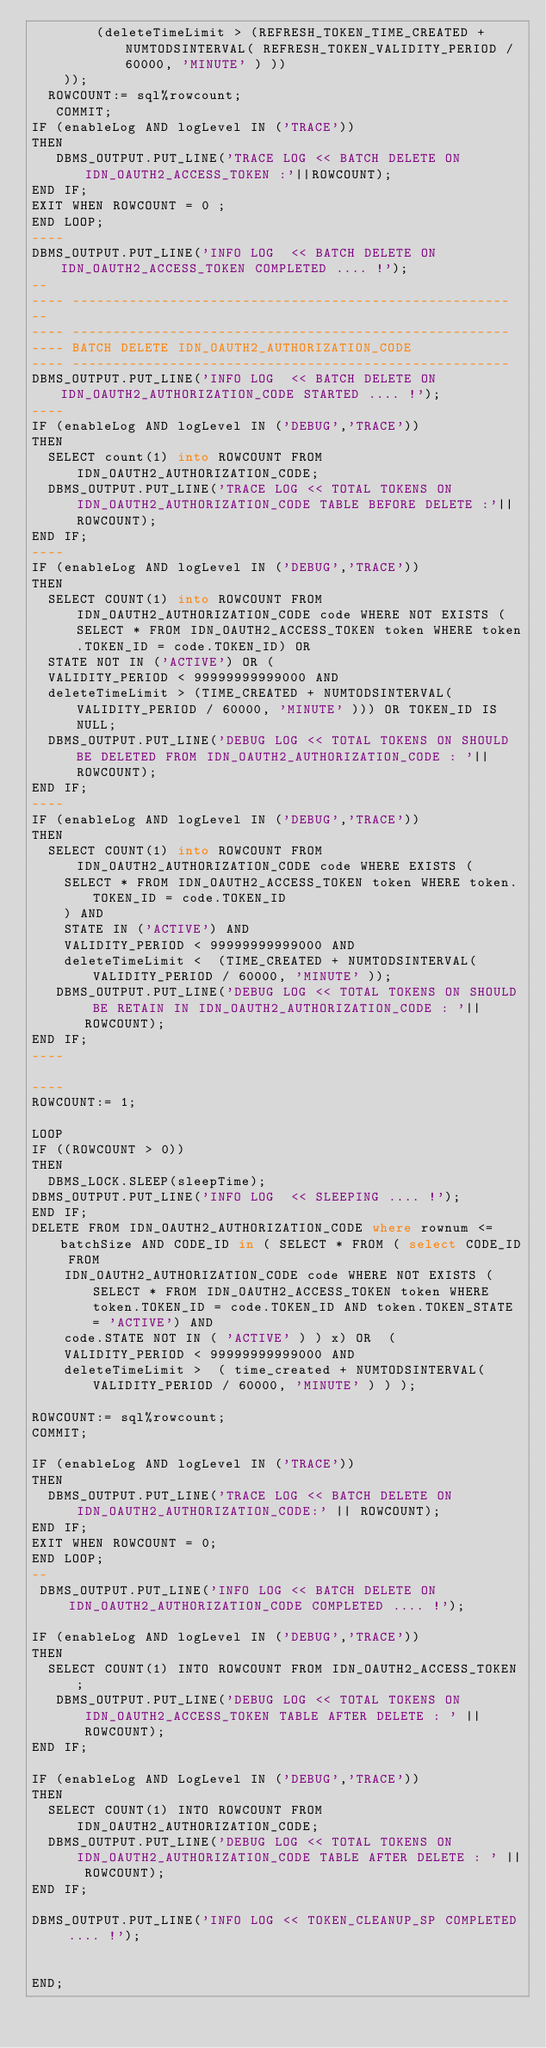<code> <loc_0><loc_0><loc_500><loc_500><_SQL_>        (deleteTimeLimit > (REFRESH_TOKEN_TIME_CREATED + NUMTODSINTERVAL( REFRESH_TOKEN_VALIDITY_PERIOD / 60000, 'MINUTE' ) ))
    ));
  ROWCOUNT:= sql%rowcount;
   COMMIT;
IF (enableLog AND logLevel IN ('TRACE'))
THEN
   DBMS_OUTPUT.PUT_LINE('TRACE LOG << BATCH DELETE ON IDN_OAUTH2_ACCESS_TOKEN :'||ROWCOUNT);
END IF;
EXIT WHEN ROWCOUNT = 0 ;
END LOOP;
----
DBMS_OUTPUT.PUT_LINE('INFO LOG  << BATCH DELETE ON IDN_OAUTH2_ACCESS_TOKEN COMPLETED .... !');
--
---- ------------------------------------------------------
--
---- ------------------------------------------------------
---- BATCH DELETE IDN_OAUTH2_AUTHORIZATION_CODE
---- ------------------------------------------------------
DBMS_OUTPUT.PUT_LINE('INFO LOG  << BATCH DELETE ON IDN_OAUTH2_AUTHORIZATION_CODE STARTED .... !');
----
IF (enableLog AND logLevel IN ('DEBUG','TRACE'))
THEN
  SELECT count(1) into ROWCOUNT FROM IDN_OAUTH2_AUTHORIZATION_CODE;
  DBMS_OUTPUT.PUT_LINE('TRACE LOG << TOTAL TOKENS ON IDN_OAUTH2_AUTHORIZATION_CODE TABLE BEFORE DELETE :'||ROWCOUNT);
END IF;
----
IF (enableLog AND logLevel IN ('DEBUG','TRACE'))
THEN
  SELECT COUNT(1) into ROWCOUNT FROM IDN_OAUTH2_AUTHORIZATION_CODE code WHERE NOT EXISTS (SELECT * FROM IDN_OAUTH2_ACCESS_TOKEN token WHERE token.TOKEN_ID = code.TOKEN_ID) OR 
  STATE NOT IN ('ACTIVE') OR (
  VALIDITY_PERIOD < 99999999999000 AND
  deleteTimeLimit > (TIME_CREATED + NUMTODSINTERVAL( VALIDITY_PERIOD / 60000, 'MINUTE' ))) OR TOKEN_ID IS NULL;
  DBMS_OUTPUT.PUT_LINE('DEBUG LOG << TOTAL TOKENS ON SHOULD BE DELETED FROM IDN_OAUTH2_AUTHORIZATION_CODE : '||ROWCOUNT);
END IF;
----
IF (enableLog AND logLevel IN ('DEBUG','TRACE'))
THEN
  SELECT COUNT(1) into ROWCOUNT FROM IDN_OAUTH2_AUTHORIZATION_CODE code WHERE EXISTS (
    SELECT * FROM IDN_OAUTH2_ACCESS_TOKEN token WHERE token.TOKEN_ID = code.TOKEN_ID
    ) AND 
    STATE IN ('ACTIVE') AND 
    VALIDITY_PERIOD < 99999999999000 AND
    deleteTimeLimit <  (TIME_CREATED + NUMTODSINTERVAL( VALIDITY_PERIOD / 60000, 'MINUTE' ));
   DBMS_OUTPUT.PUT_LINE('DEBUG LOG << TOTAL TOKENS ON SHOULD BE RETAIN IN IDN_OAUTH2_AUTHORIZATION_CODE : '||ROWCOUNT);
END IF;
----

----
ROWCOUNT:= 1;

LOOP
IF ((ROWCOUNT > 0))
THEN
  DBMS_LOCK.SLEEP(sleepTime);
DBMS_OUTPUT.PUT_LINE('INFO LOG  << SLEEPING .... !');
END IF;
DELETE FROM IDN_OAUTH2_AUTHORIZATION_CODE where rownum <= batchSize AND CODE_ID in ( SELECT * FROM ( select CODE_ID FROM
    IDN_OAUTH2_AUTHORIZATION_CODE code WHERE NOT EXISTS ( SELECT * FROM IDN_OAUTH2_ACCESS_TOKEN token WHERE token.TOKEN_ID = code.TOKEN_ID AND token.TOKEN_STATE = 'ACTIVE') AND 
    code.STATE NOT IN ( 'ACTIVE' ) ) x) OR  (
    VALIDITY_PERIOD < 99999999999000 AND
    deleteTimeLimit >  ( time_created + NUMTODSINTERVAL( VALIDITY_PERIOD / 60000, 'MINUTE' ) ) );

ROWCOUNT:= sql%rowcount;
COMMIT;

IF (enableLog AND logLevel IN ('TRACE'))
THEN
  DBMS_OUTPUT.PUT_LINE('TRACE LOG << BATCH DELETE ON IDN_OAUTH2_AUTHORIZATION_CODE:' || ROWCOUNT);
END IF;
EXIT WHEN ROWCOUNT = 0;
END LOOP;
--
 DBMS_OUTPUT.PUT_LINE('INFO LOG << BATCH DELETE ON IDN_OAUTH2_AUTHORIZATION_CODE COMPLETED .... !');

IF (enableLog AND logLevel IN ('DEBUG','TRACE'))
THEN
  SELECT COUNT(1) INTO ROWCOUNT FROM IDN_OAUTH2_ACCESS_TOKEN;
   DBMS_OUTPUT.PUT_LINE('DEBUG LOG << TOTAL TOKENS ON IDN_OAUTH2_ACCESS_TOKEN TABLE AFTER DELETE : ' ||ROWCOUNT);
END IF;

IF (enableLog AND LogLevel IN ('DEBUG','TRACE'))
THEN
  SELECT COUNT(1) INTO ROWCOUNT FROM IDN_OAUTH2_AUTHORIZATION_CODE;
  DBMS_OUTPUT.PUT_LINE('DEBUG LOG << TOTAL TOKENS ON IDN_OAUTH2_AUTHORIZATION_CODE TABLE AFTER DELETE : ' || ROWCOUNT);
END IF;

DBMS_OUTPUT.PUT_LINE('INFO LOG << TOKEN_CLEANUP_SP COMPLETED .... !');


END;
</code> 